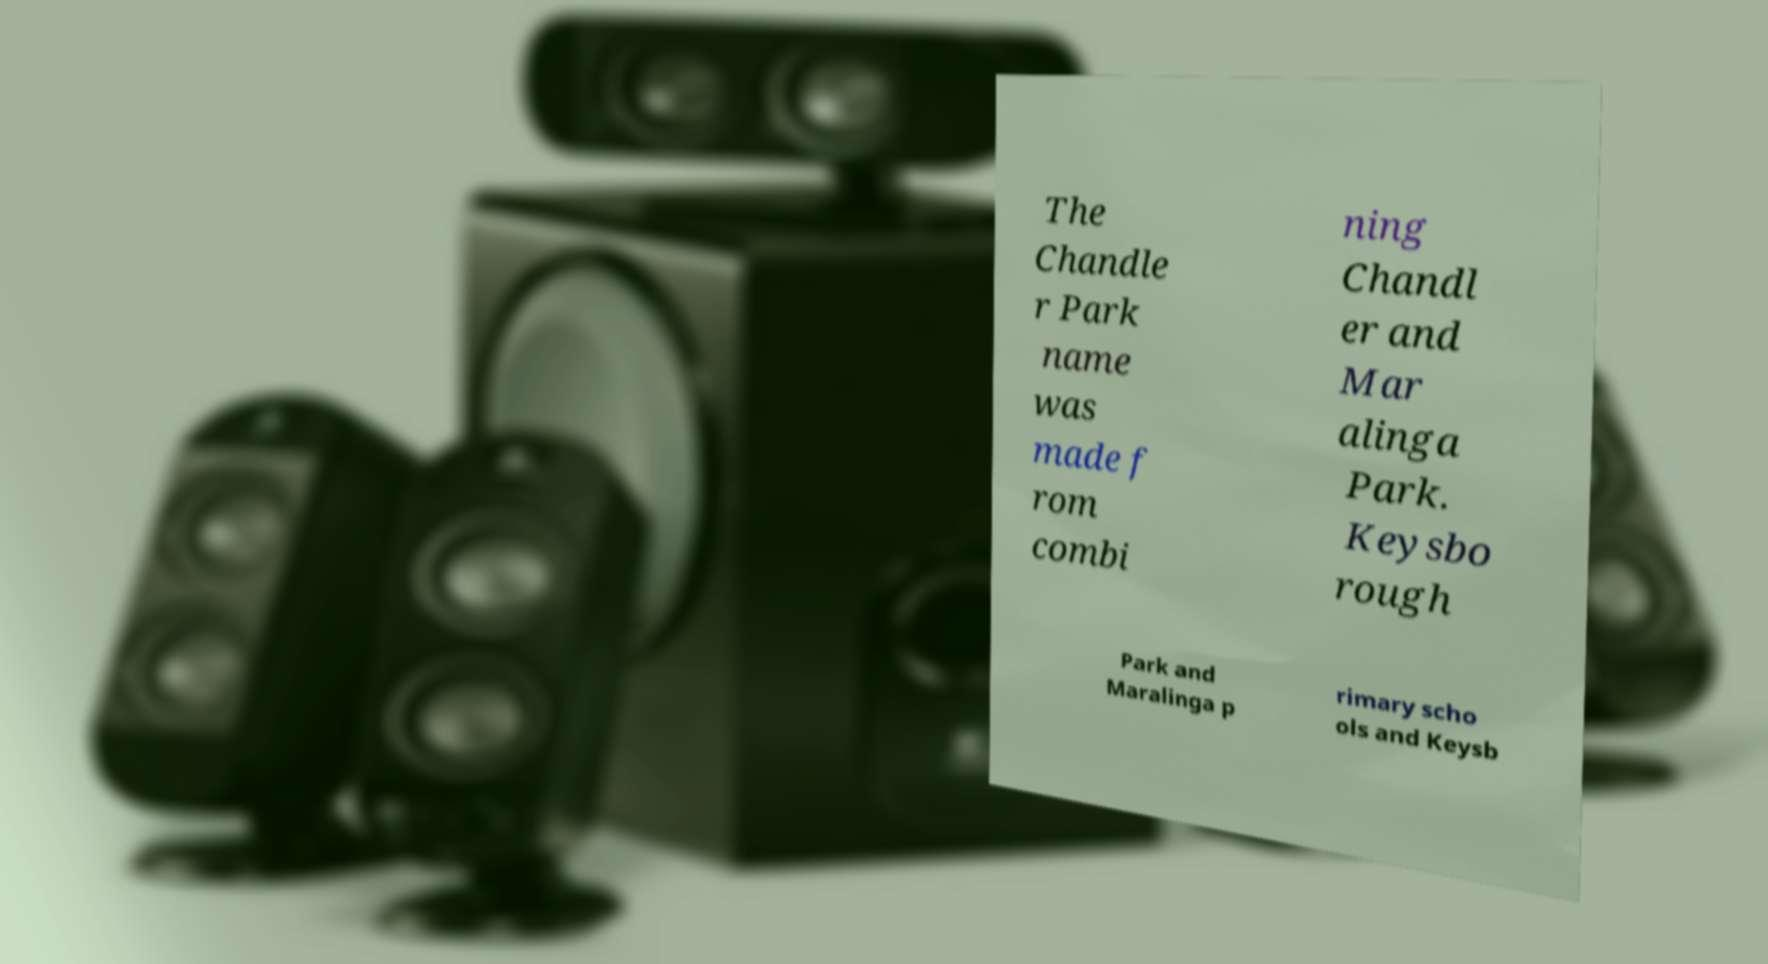There's text embedded in this image that I need extracted. Can you transcribe it verbatim? The Chandle r Park name was made f rom combi ning Chandl er and Mar alinga Park. Keysbo rough Park and Maralinga p rimary scho ols and Keysb 